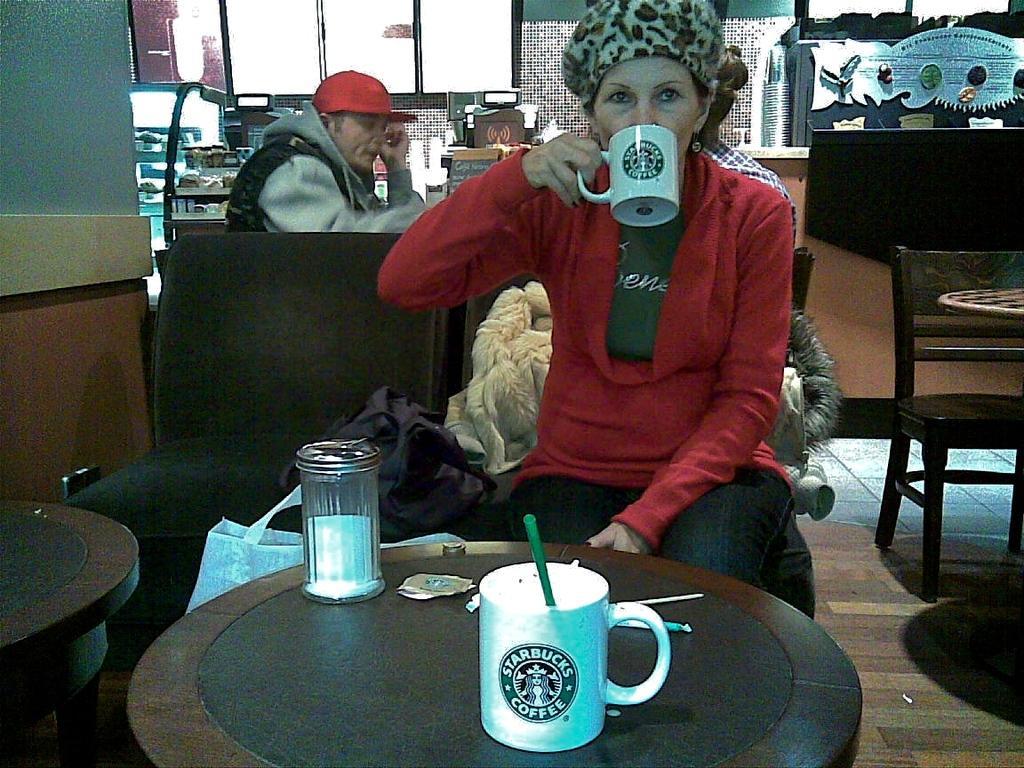Please provide a concise description of this image. In this image we can see a woman on a chair holding a cup sitting beside a table containing a cup with a straw and a container on it. We can also see some chairs, tables, a bag, cloth, some people sitting, some devices, some objects on the racks, a wall and the windows. 